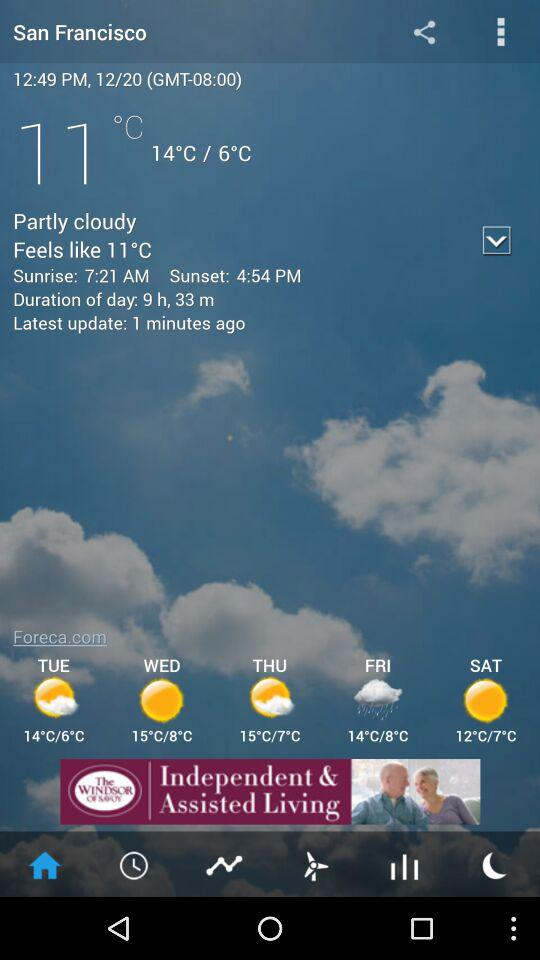What is the temperature? The temperature is 11 °C. 